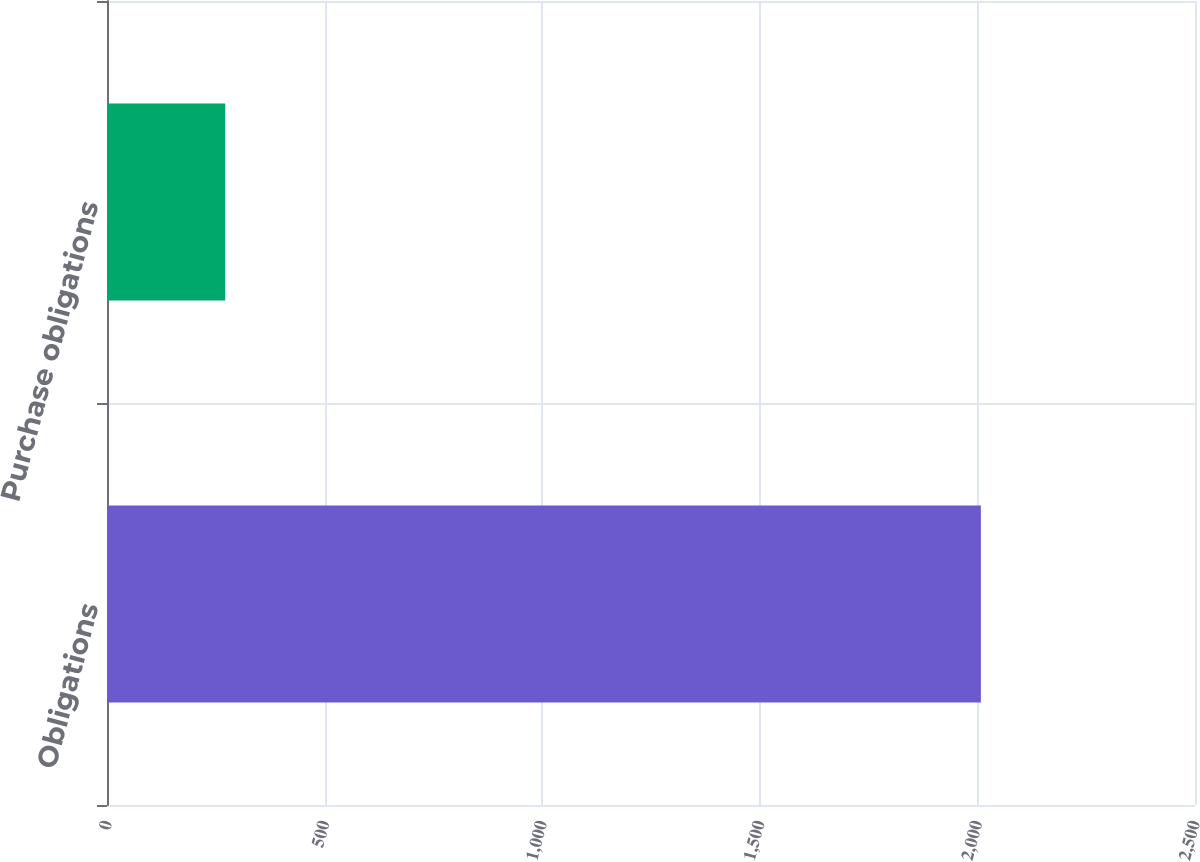Convert chart to OTSL. <chart><loc_0><loc_0><loc_500><loc_500><bar_chart><fcel>Obligations<fcel>Purchase obligations<nl><fcel>2008<fcel>271.8<nl></chart> 